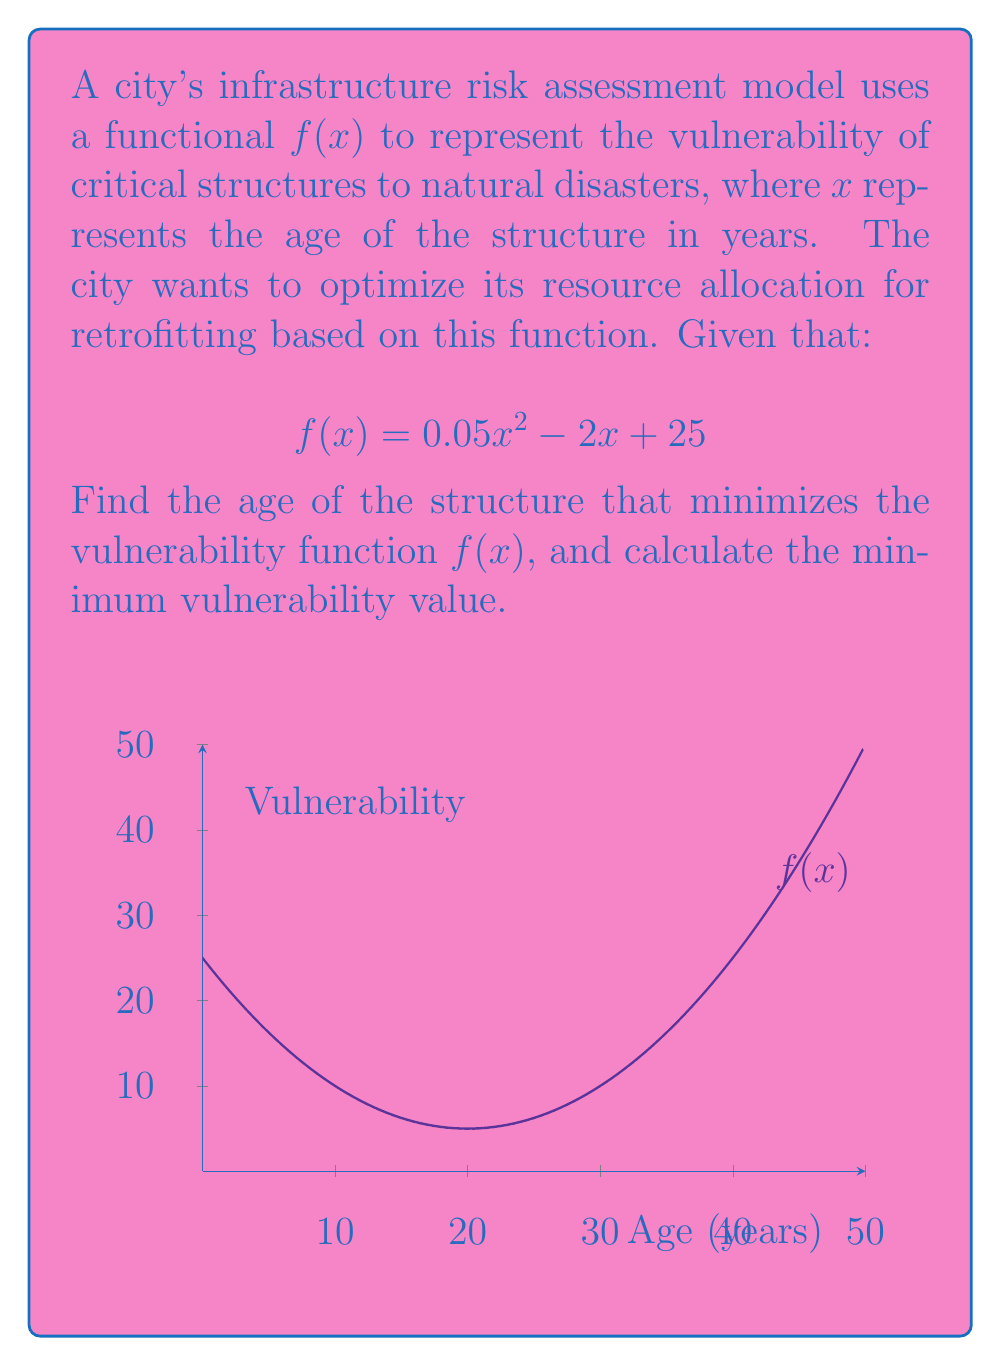Help me with this question. To find the age that minimizes the vulnerability function, we need to follow these steps:

1) First, we need to find the derivative of $f(x)$:
   $$f'(x) = 0.1x - 2$$

2) To find the minimum, we set the derivative equal to zero and solve for x:
   $$0.1x - 2 = 0$$
   $$0.1x = 2$$
   $$x = 20$$

3) To confirm this is a minimum (not a maximum), we can check the second derivative:
   $$f''(x) = 0.1$$
   Since $f''(x) > 0$, this confirms we have found a minimum.

4) Now that we know the age that minimizes vulnerability is 20 years, we can calculate the minimum vulnerability by plugging this value back into our original function:

   $$f(20) = 0.05(20)^2 - 2(20) + 25$$
   $$= 0.05(400) - 40 + 25$$
   $$= 20 - 40 + 25$$
   $$= 5$$

Therefore, the vulnerability is minimized when structures are 20 years old, with a minimum vulnerability value of 5.
Answer: Age: 20 years; Minimum vulnerability: 5 